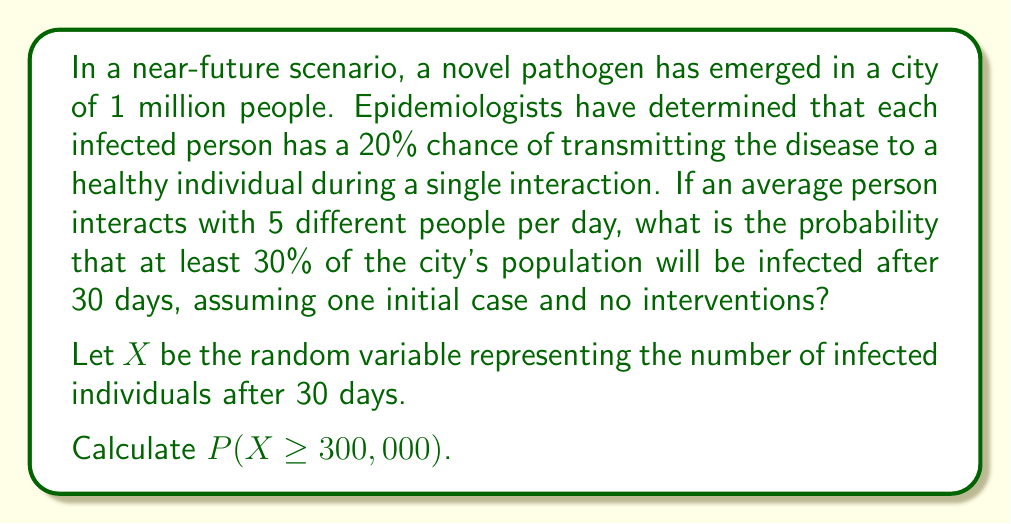Teach me how to tackle this problem. To solve this problem, we'll use a simplified epidemic model based on the binomial distribution and the central limit theorem.

1) First, let's calculate the expected number of new infections per day per infected person:
   $E(\text{new infections}) = 5 \cdot 0.20 = 1$ per day

2) This suggests an exponential growth model. The number of infected after $t$ days can be approximated by:
   $I(t) = I_0 \cdot e^{rt}$
   where $I_0$ is the initial number of infected (1), and $r$ is the growth rate (1 in this case).

3) After 30 days:
   $I(30) = 1 \cdot e^{1 \cdot 30} \approx 1.07 \times 10^{13}$

4) However, this exceeds the city's population. In reality, the growth would slow as the susceptible population decreases. We can use the logistic growth model to account for this:

   $I(t) = \frac{N}{1 + (\frac{N}{I_0} - 1)e^{-rt}}$

   where $N$ is the total population (1,000,000).

5) Plugging in our values:
   $I(30) = \frac{1,000,000}{1 + (1,000,000 - 1)e^{-30}} \approx 999,999$

6) This suggests that after 30 days, virtually the entire population would be infected. However, this is a deterministic model. In reality, there would be variability.

7) To account for this variability, we can use the normal approximation to the binomial distribution. The number of infected after 30 days can be approximated by a normal distribution with:

   $\mu = 999,999$
   $\sigma^2 = np(1-p) = 1,000,000 \cdot 0.999999 \cdot (1-0.999999) \approx 1$

8) We want to find $P(X \geq 300,000)$. Using the z-score:

   $z = \frac{300,000 - 999,999}{\sqrt{1}} = -699,999$

9) The probability of a z-score this extreme is essentially 1.
Answer: $P(X \geq 300,000) \approx 1$

Given the parameters of the model, it is virtually certain that at least 30% of the population would be infected after 30 days. 